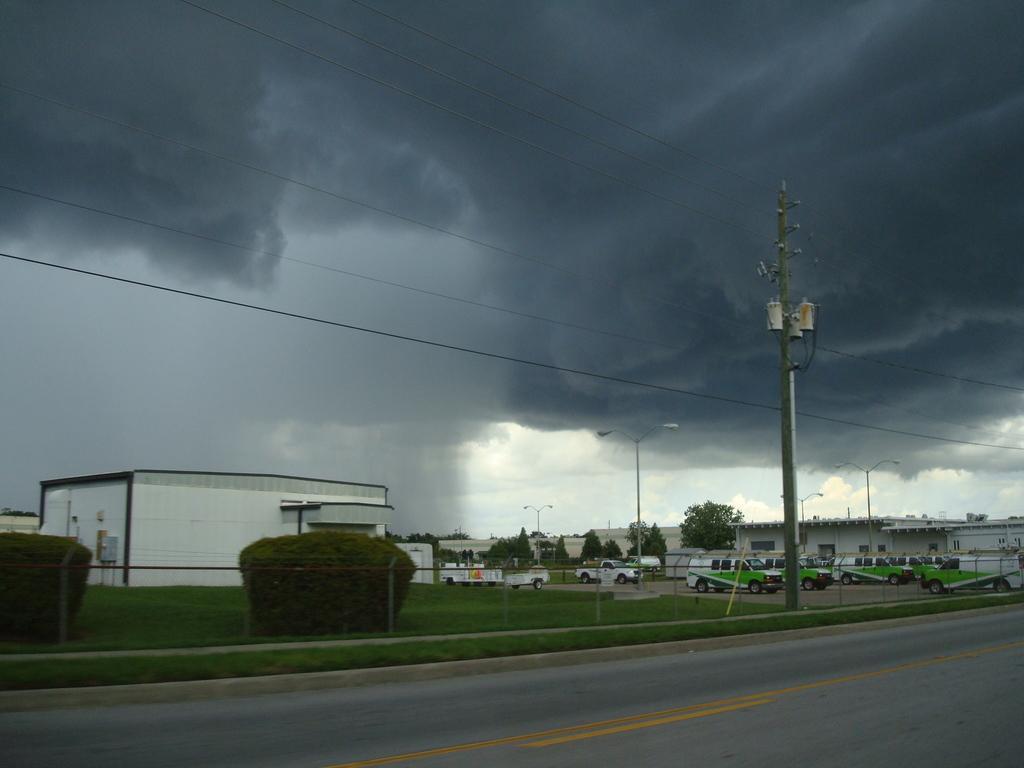How would you summarize this image in a sentence or two? In this image we can see the road, current pole, wires, fence, shrubs, grass, vehicles parked here, light poles, houses, trees and the cloudy sky in the background. 